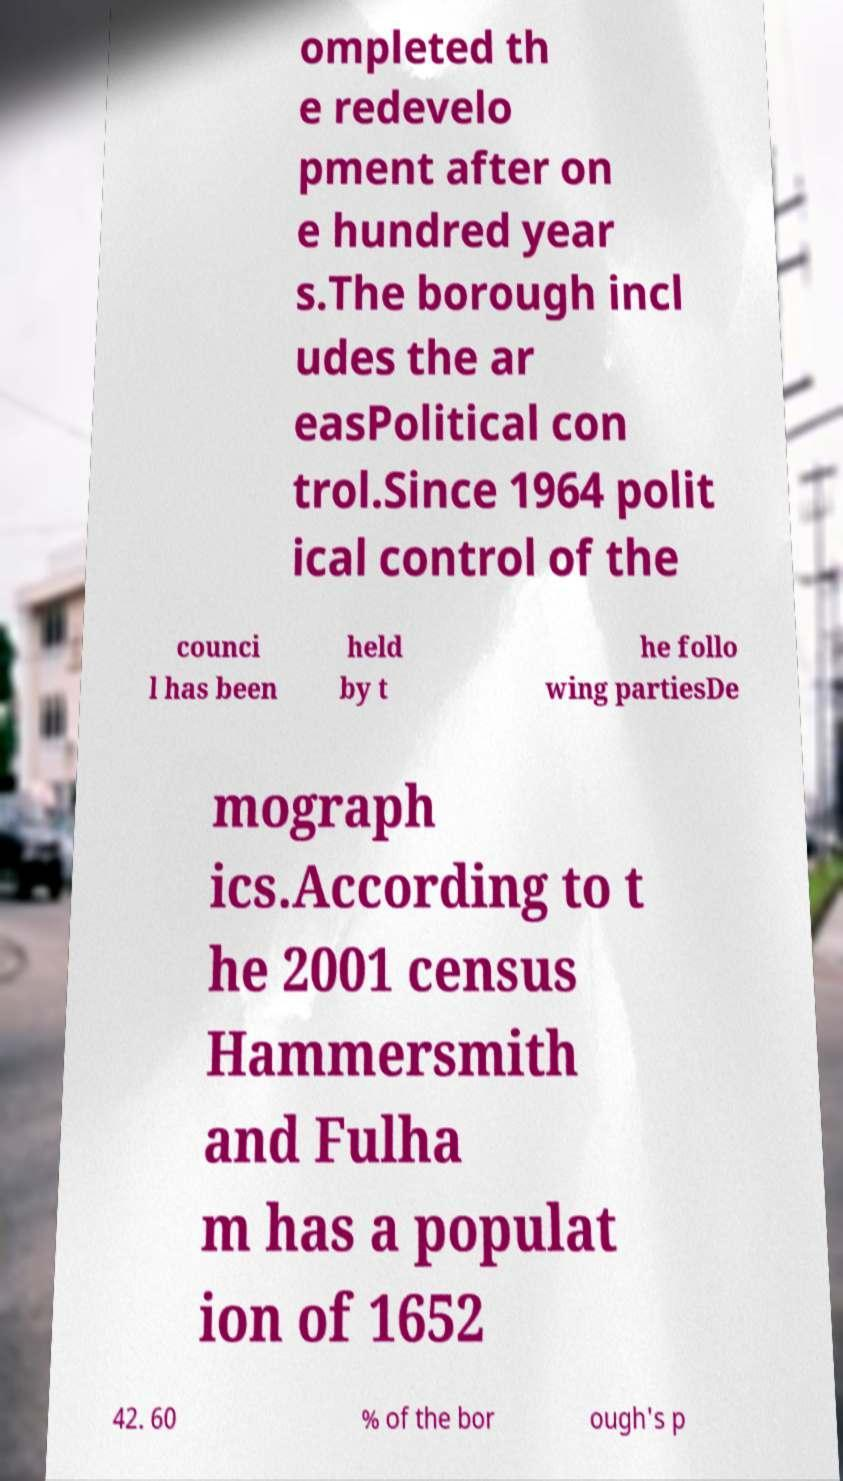Can you read and provide the text displayed in the image?This photo seems to have some interesting text. Can you extract and type it out for me? ompleted th e redevelo pment after on e hundred year s.The borough incl udes the ar easPolitical con trol.Since 1964 polit ical control of the counci l has been held by t he follo wing partiesDe mograph ics.According to t he 2001 census Hammersmith and Fulha m has a populat ion of 1652 42. 60 % of the bor ough's p 